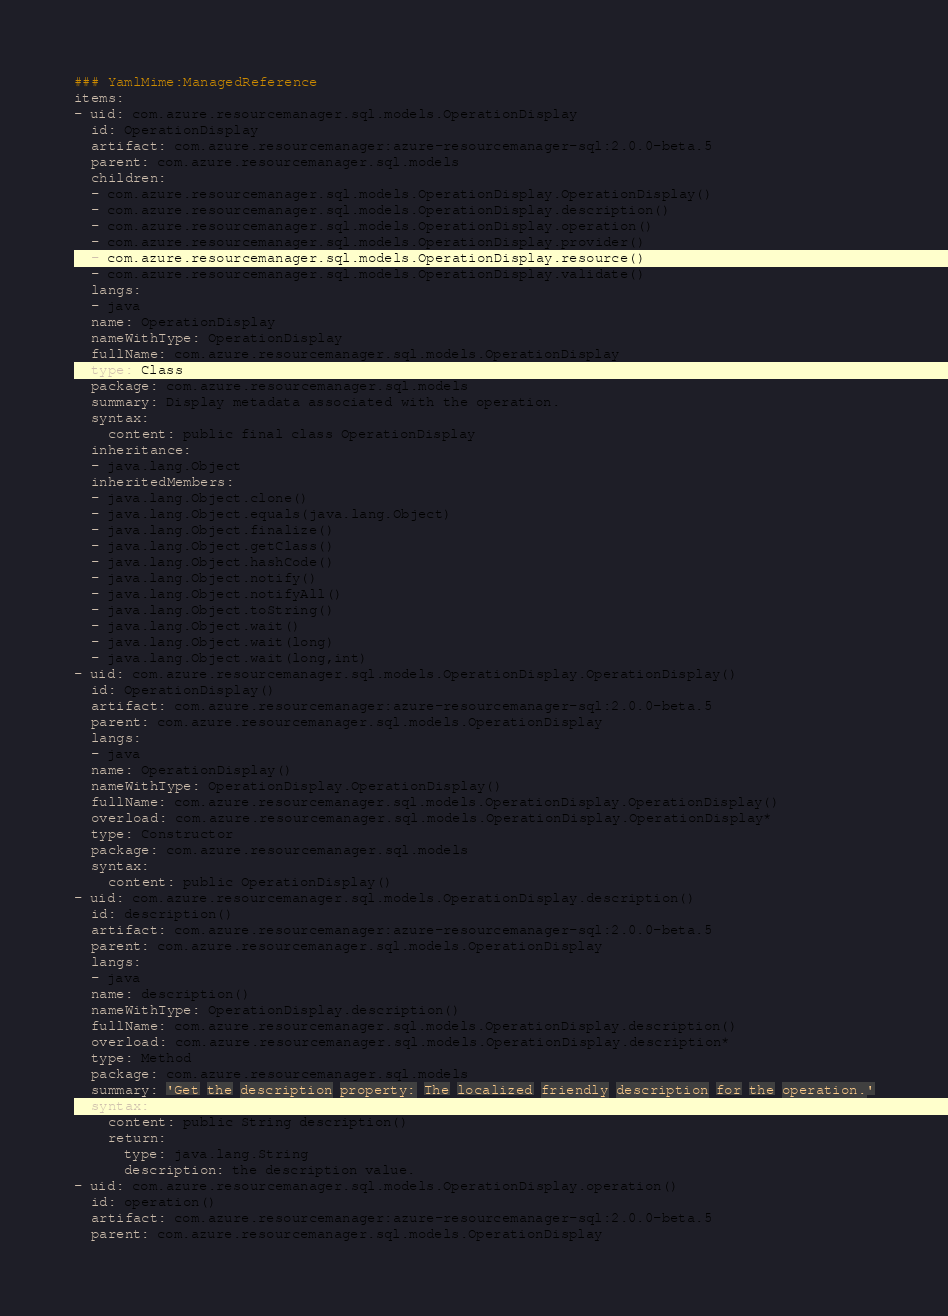<code> <loc_0><loc_0><loc_500><loc_500><_YAML_>### YamlMime:ManagedReference
items:
- uid: com.azure.resourcemanager.sql.models.OperationDisplay
  id: OperationDisplay
  artifact: com.azure.resourcemanager:azure-resourcemanager-sql:2.0.0-beta.5
  parent: com.azure.resourcemanager.sql.models
  children:
  - com.azure.resourcemanager.sql.models.OperationDisplay.OperationDisplay()
  - com.azure.resourcemanager.sql.models.OperationDisplay.description()
  - com.azure.resourcemanager.sql.models.OperationDisplay.operation()
  - com.azure.resourcemanager.sql.models.OperationDisplay.provider()
  - com.azure.resourcemanager.sql.models.OperationDisplay.resource()
  - com.azure.resourcemanager.sql.models.OperationDisplay.validate()
  langs:
  - java
  name: OperationDisplay
  nameWithType: OperationDisplay
  fullName: com.azure.resourcemanager.sql.models.OperationDisplay
  type: Class
  package: com.azure.resourcemanager.sql.models
  summary: Display metadata associated with the operation.
  syntax:
    content: public final class OperationDisplay
  inheritance:
  - java.lang.Object
  inheritedMembers:
  - java.lang.Object.clone()
  - java.lang.Object.equals(java.lang.Object)
  - java.lang.Object.finalize()
  - java.lang.Object.getClass()
  - java.lang.Object.hashCode()
  - java.lang.Object.notify()
  - java.lang.Object.notifyAll()
  - java.lang.Object.toString()
  - java.lang.Object.wait()
  - java.lang.Object.wait(long)
  - java.lang.Object.wait(long,int)
- uid: com.azure.resourcemanager.sql.models.OperationDisplay.OperationDisplay()
  id: OperationDisplay()
  artifact: com.azure.resourcemanager:azure-resourcemanager-sql:2.0.0-beta.5
  parent: com.azure.resourcemanager.sql.models.OperationDisplay
  langs:
  - java
  name: OperationDisplay()
  nameWithType: OperationDisplay.OperationDisplay()
  fullName: com.azure.resourcemanager.sql.models.OperationDisplay.OperationDisplay()
  overload: com.azure.resourcemanager.sql.models.OperationDisplay.OperationDisplay*
  type: Constructor
  package: com.azure.resourcemanager.sql.models
  syntax:
    content: public OperationDisplay()
- uid: com.azure.resourcemanager.sql.models.OperationDisplay.description()
  id: description()
  artifact: com.azure.resourcemanager:azure-resourcemanager-sql:2.0.0-beta.5
  parent: com.azure.resourcemanager.sql.models.OperationDisplay
  langs:
  - java
  name: description()
  nameWithType: OperationDisplay.description()
  fullName: com.azure.resourcemanager.sql.models.OperationDisplay.description()
  overload: com.azure.resourcemanager.sql.models.OperationDisplay.description*
  type: Method
  package: com.azure.resourcemanager.sql.models
  summary: 'Get the description property: The localized friendly description for the operation.'
  syntax:
    content: public String description()
    return:
      type: java.lang.String
      description: the description value.
- uid: com.azure.resourcemanager.sql.models.OperationDisplay.operation()
  id: operation()
  artifact: com.azure.resourcemanager:azure-resourcemanager-sql:2.0.0-beta.5
  parent: com.azure.resourcemanager.sql.models.OperationDisplay</code> 